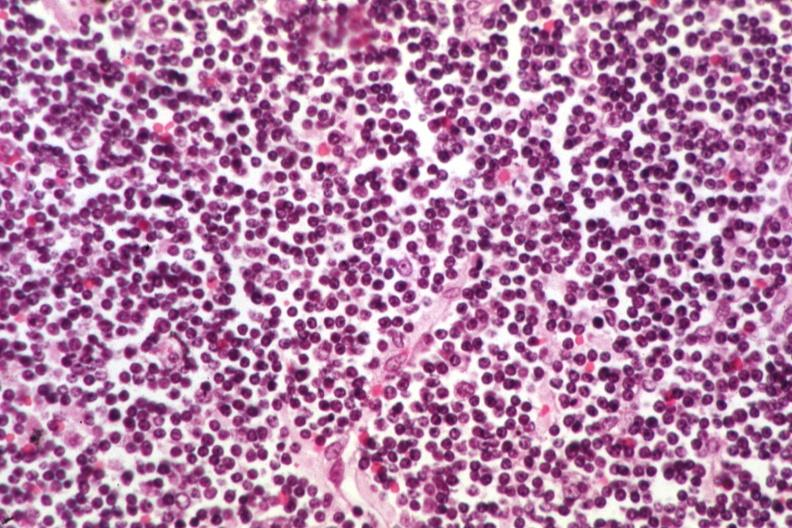s lymph node present?
Answer the question using a single word or phrase. Yes 